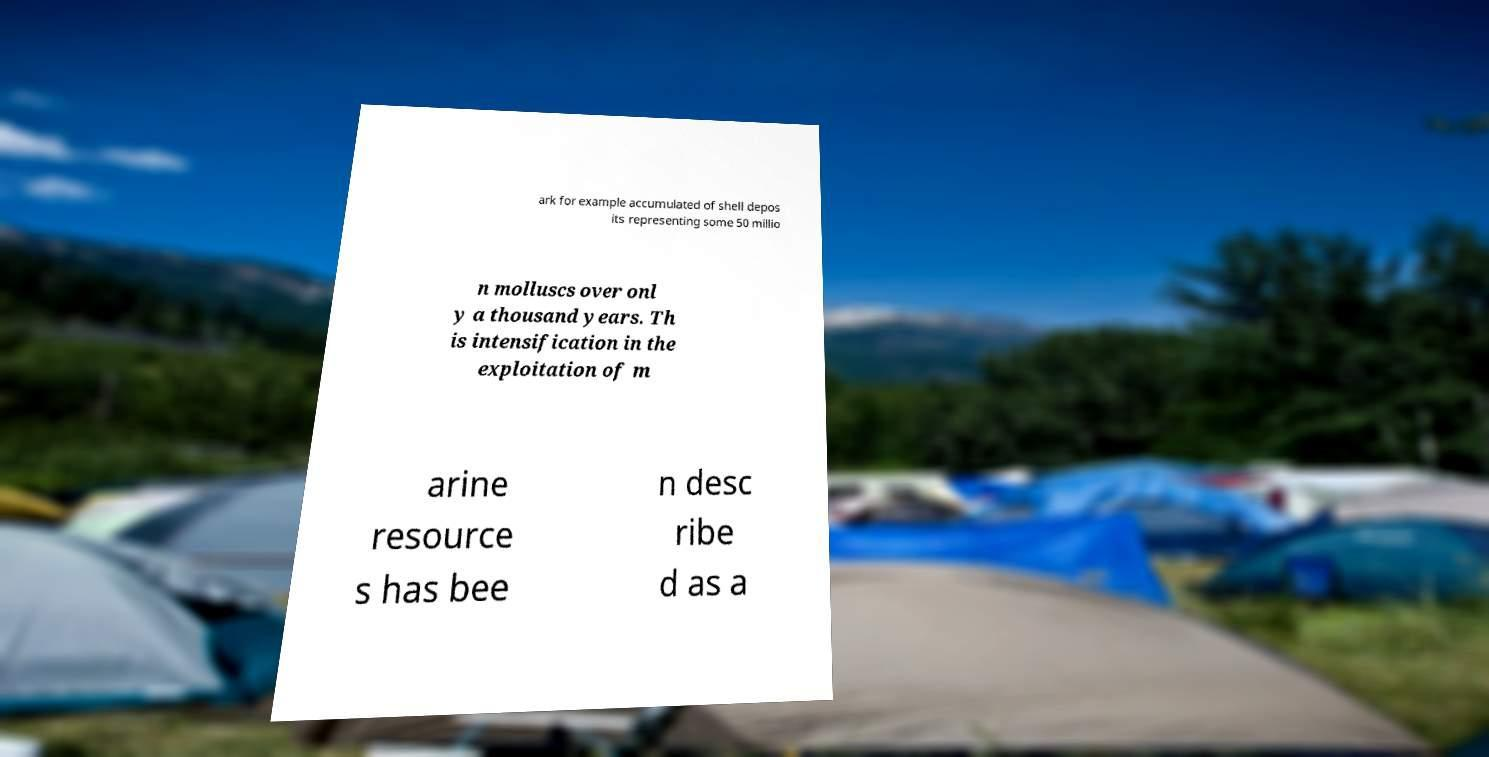What messages or text are displayed in this image? I need them in a readable, typed format. ark for example accumulated of shell depos its representing some 50 millio n molluscs over onl y a thousand years. Th is intensification in the exploitation of m arine resource s has bee n desc ribe d as a 